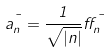<formula> <loc_0><loc_0><loc_500><loc_500>a _ { n } ^ { \mu } = \frac { 1 } { \sqrt { | n | } } \alpha _ { n } ^ { \mu }</formula> 